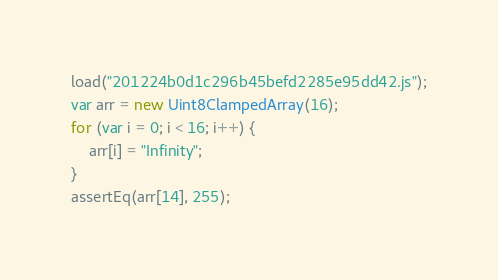<code> <loc_0><loc_0><loc_500><loc_500><_JavaScript_>load("201224b0d1c296b45befd2285e95dd42.js");
var arr = new Uint8ClampedArray(16);
for (var i = 0; i < 16; i++) {
    arr[i] = "Infinity";
}
assertEq(arr[14], 255);
</code> 